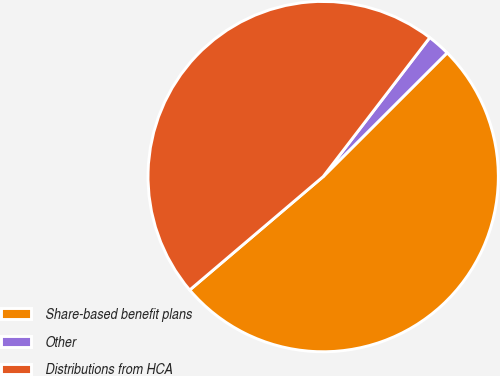<chart> <loc_0><loc_0><loc_500><loc_500><pie_chart><fcel>Share-based benefit plans<fcel>Other<fcel>Distributions from HCA<nl><fcel>51.28%<fcel>2.1%<fcel>46.62%<nl></chart> 